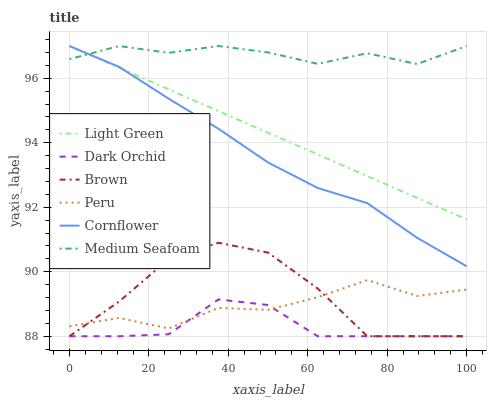Does Dark Orchid have the minimum area under the curve?
Answer yes or no. Yes. Does Medium Seafoam have the maximum area under the curve?
Answer yes or no. Yes. Does Light Green have the minimum area under the curve?
Answer yes or no. No. Does Light Green have the maximum area under the curve?
Answer yes or no. No. Is Light Green the smoothest?
Answer yes or no. Yes. Is Peru the roughest?
Answer yes or no. Yes. Is Cornflower the smoothest?
Answer yes or no. No. Is Cornflower the roughest?
Answer yes or no. No. Does Brown have the lowest value?
Answer yes or no. Yes. Does Light Green have the lowest value?
Answer yes or no. No. Does Medium Seafoam have the highest value?
Answer yes or no. Yes. Does Dark Orchid have the highest value?
Answer yes or no. No. Is Dark Orchid less than Cornflower?
Answer yes or no. Yes. Is Cornflower greater than Peru?
Answer yes or no. Yes. Does Peru intersect Dark Orchid?
Answer yes or no. Yes. Is Peru less than Dark Orchid?
Answer yes or no. No. Is Peru greater than Dark Orchid?
Answer yes or no. No. Does Dark Orchid intersect Cornflower?
Answer yes or no. No. 